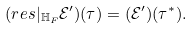Convert formula to latex. <formula><loc_0><loc_0><loc_500><loc_500>( r e s | _ { \mathbb { H } _ { F } } \mathcal { E ^ { \prime } } ) ( \tau ) = ( \mathcal { E ^ { \prime } } ) ( \tau ^ { * } ) .</formula> 